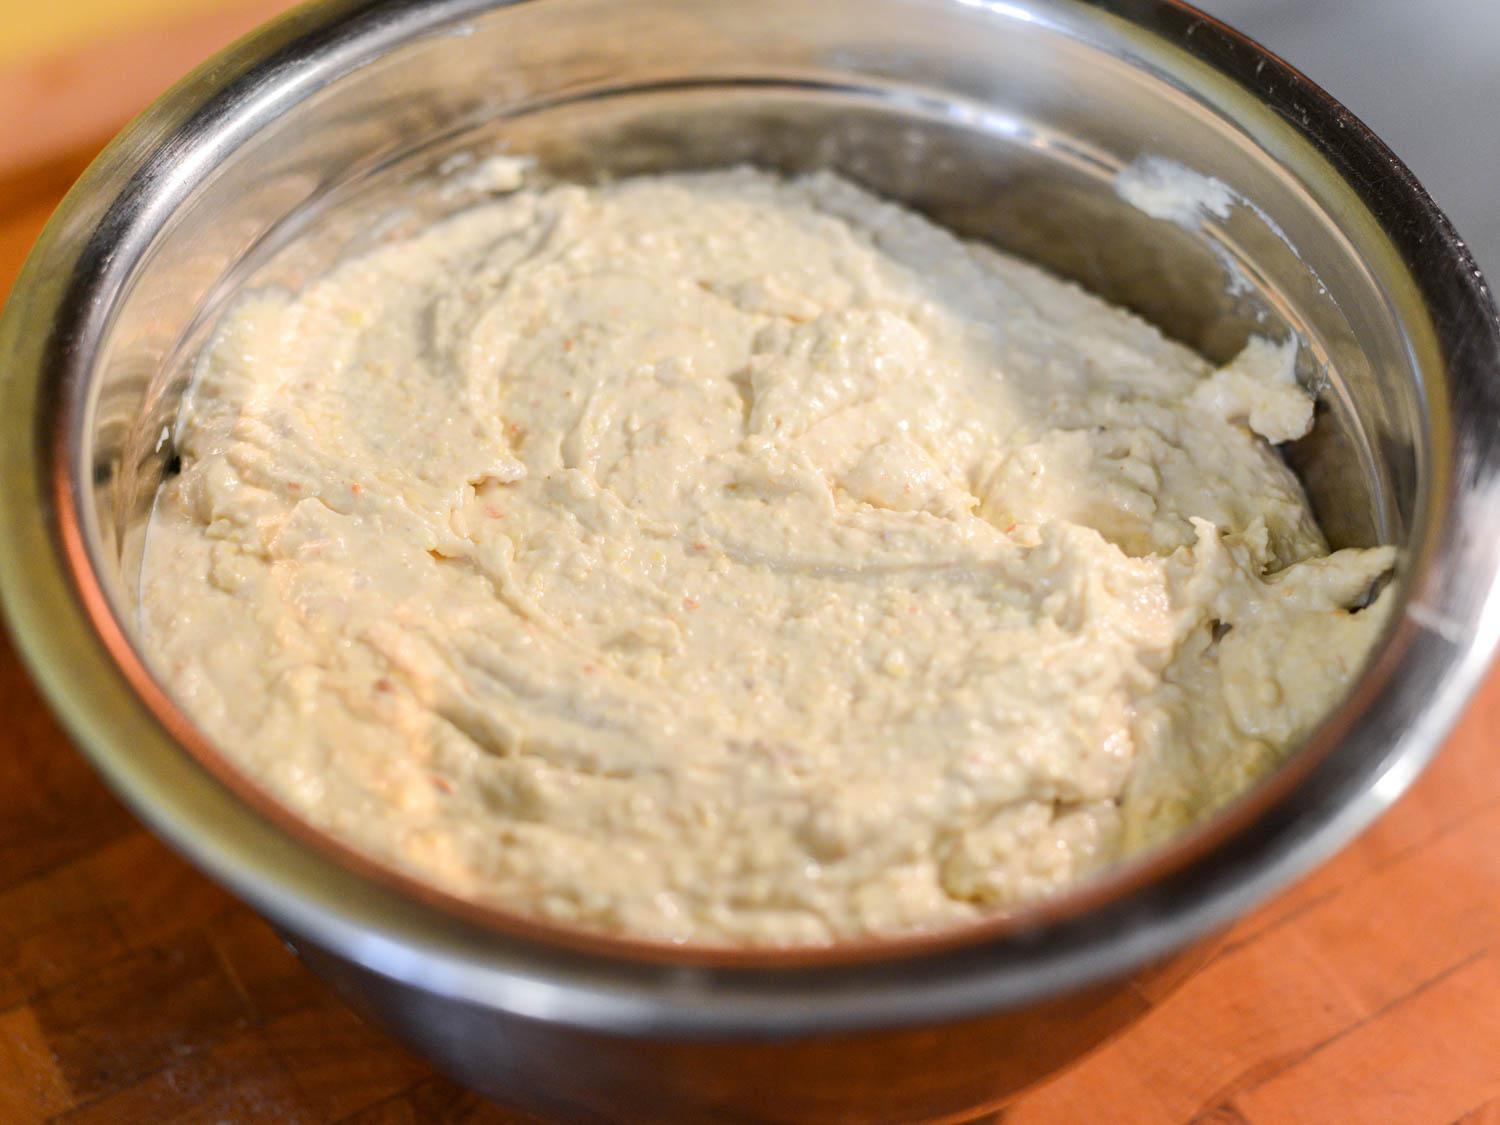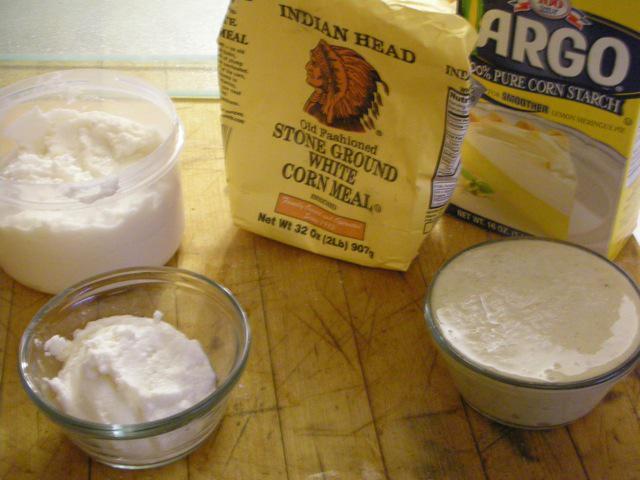The first image is the image on the left, the second image is the image on the right. Examine the images to the left and right. Is the description "One image features one rounded raw dough ball sitting on a flat surface but not in a container." accurate? Answer yes or no. No. 